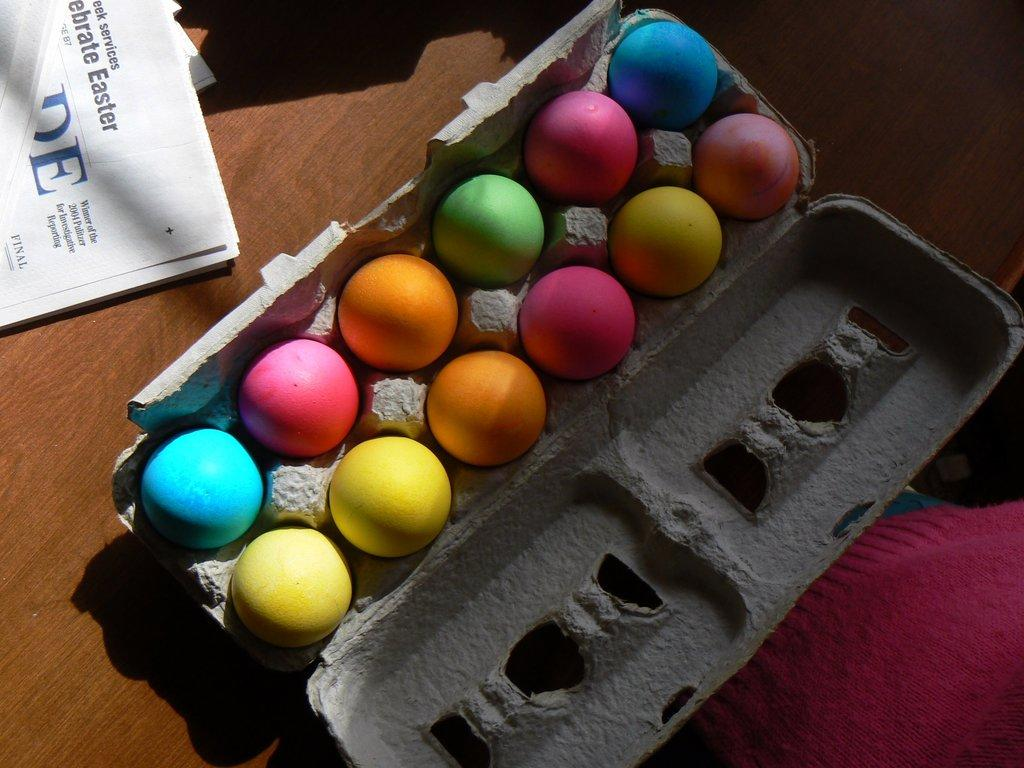What type of surface is visible in the image? There is a wooden surface in the image. What is placed on the wooden surface? There is paper and colorful balls in the image. How are the colorful balls contained? These objects are in a container. How many babies are present in the image? There are no babies present in the image. What type of leather material can be seen in the image? There is no leather material present in the image. 